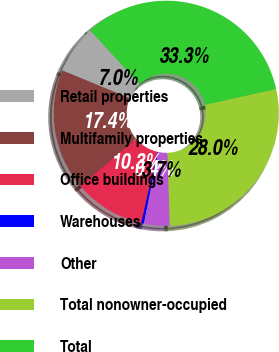Convert chart to OTSL. <chart><loc_0><loc_0><loc_500><loc_500><pie_chart><fcel>Retail properties<fcel>Multifamily properties<fcel>Office buildings<fcel>Warehouses<fcel>Other<fcel>Total nonowner-occupied<fcel>Total<nl><fcel>6.97%<fcel>17.39%<fcel>10.27%<fcel>0.38%<fcel>3.68%<fcel>27.96%<fcel>33.35%<nl></chart> 